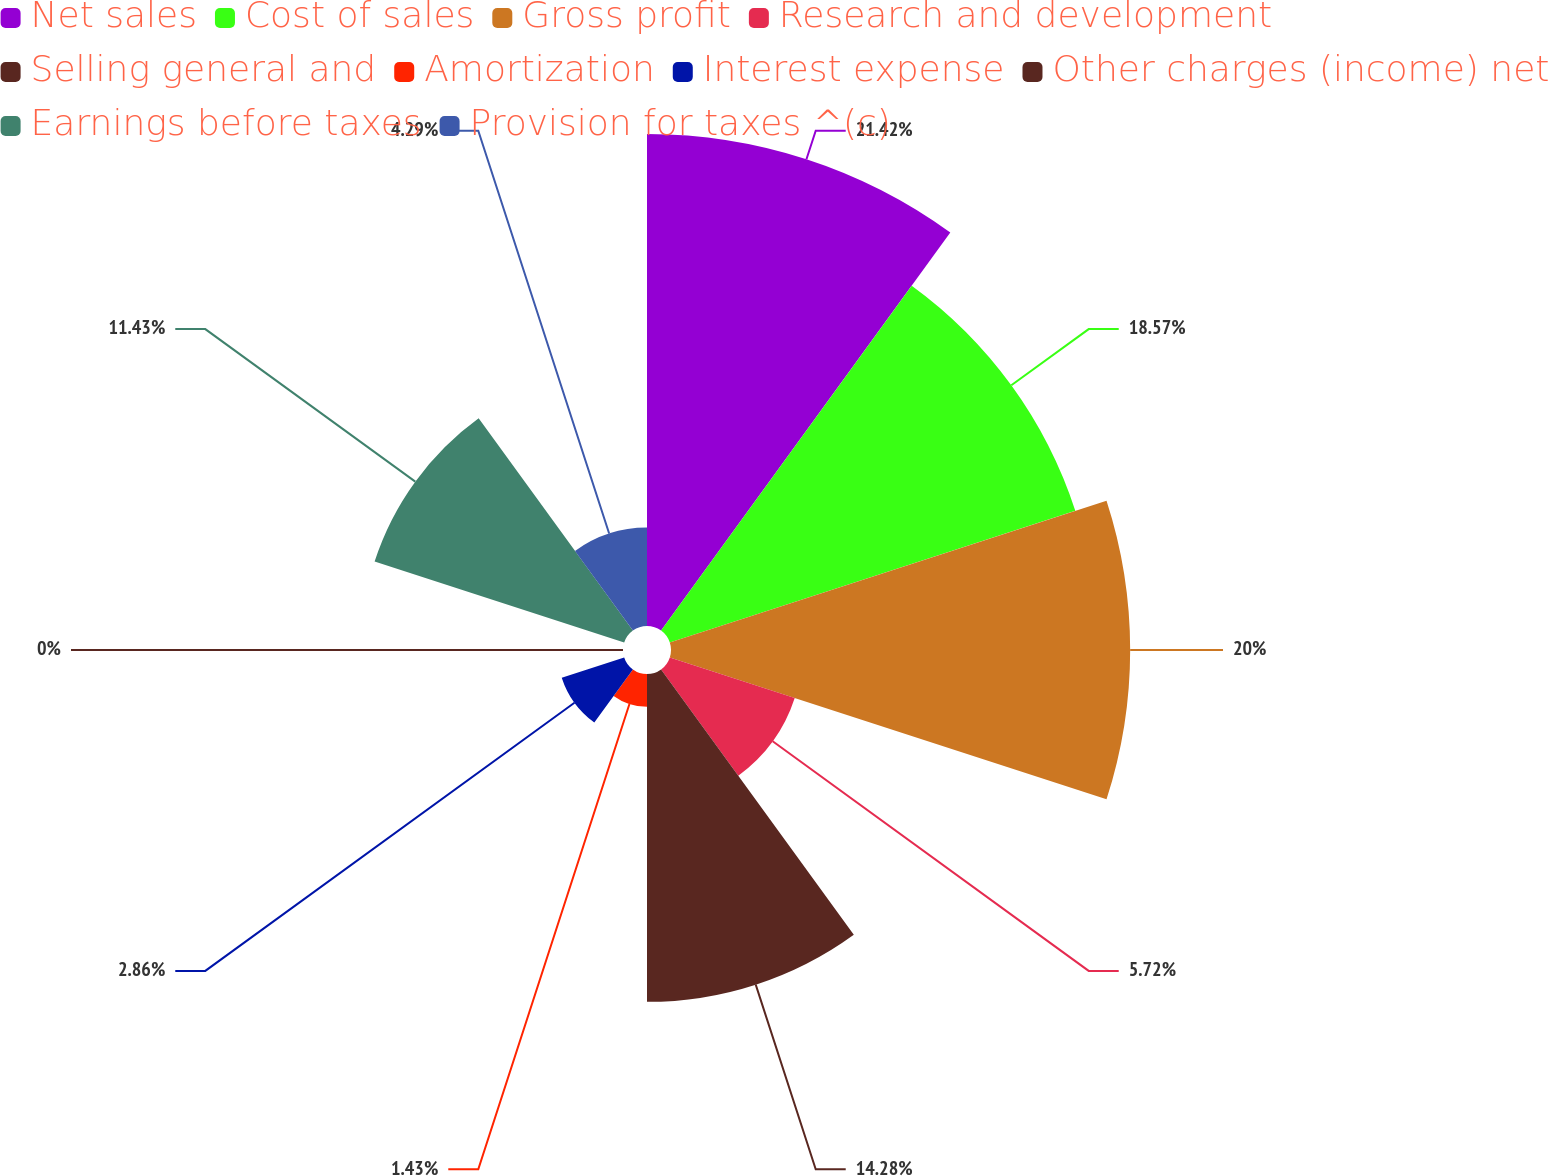Convert chart. <chart><loc_0><loc_0><loc_500><loc_500><pie_chart><fcel>Net sales<fcel>Cost of sales<fcel>Gross profit<fcel>Research and development<fcel>Selling general and<fcel>Amortization<fcel>Interest expense<fcel>Other charges (income) net<fcel>Earnings before taxes<fcel>Provision for taxes ^(c)<nl><fcel>21.43%<fcel>18.57%<fcel>20.0%<fcel>5.72%<fcel>14.28%<fcel>1.43%<fcel>2.86%<fcel>0.0%<fcel>11.43%<fcel>4.29%<nl></chart> 